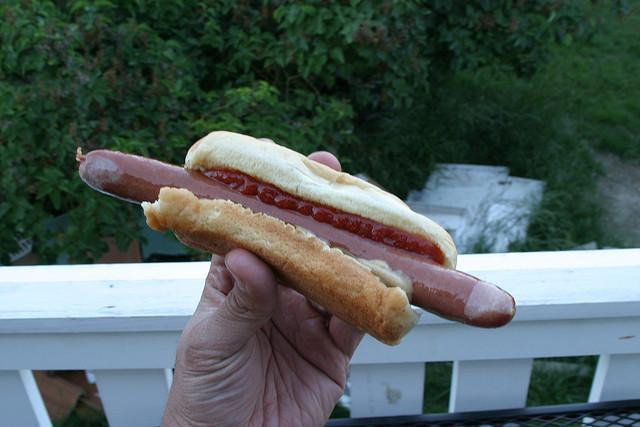Does the caption "The person is touching the hot dog." correctly depict the image?
Answer yes or no. Yes. 